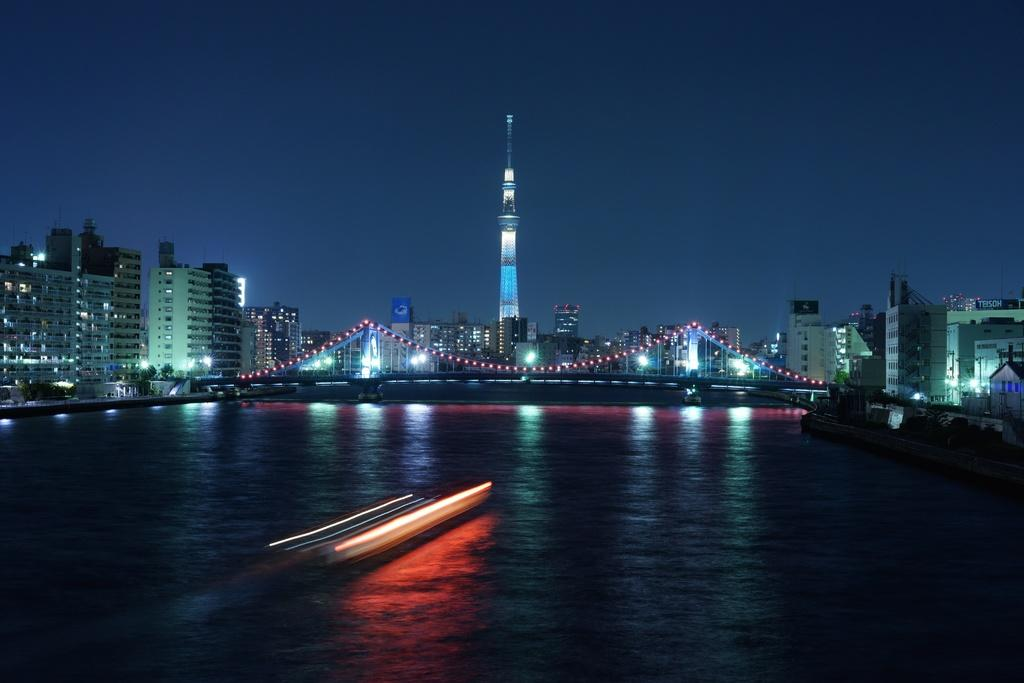What is the main object on the water in the image? There is an object on the water in the image, but the specific object is not mentioned in the facts. What can be seen in the distance behind the water? There are buildings visible in the background of the image. What type of lights are present in the image? There are lights in multi-color in the image. What color is the sky in the image? The sky is blue in the image. What is the chance of winning a prize in the image? There is no mention of a prize or any game of chance in the image, so it is not possible to determine the chance of winning a prize. What mass is the object on the water? The mass of the object on the water is not mentioned in the facts, so it cannot be determined from the image. 